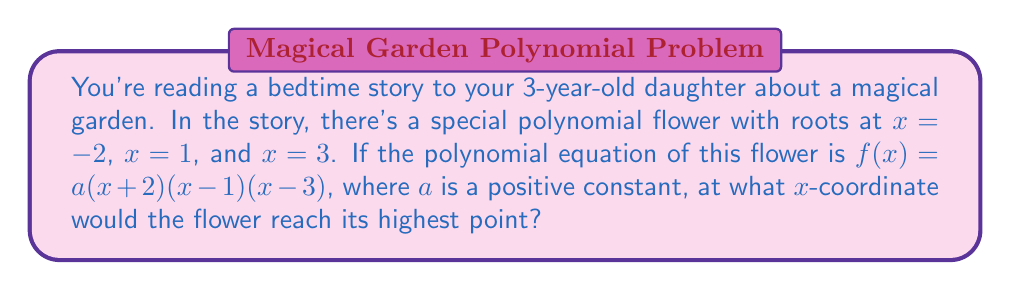What is the answer to this math problem? Let's approach this step-by-step:

1) The roots of the polynomial are at $x = -2$, $x = 1$, and $x = 3$. These are the x-intercepts of the graph.

2) Since $a$ is positive, the polynomial will open upward, meaning it will have a minimum point between its roots rather than a maximum.

3) To find the highest point (the maximum), we need to find the x-coordinate of the vertex of the parabola formed by the two outer roots.

4) The x-coordinate of the vertex of a parabola is always halfway between its roots.

5) The outer roots are at $x = -2$ and $x = 3$.

6) To find the midpoint between these roots, we use the formula:
   $$\frac{-2 + 3}{2} = \frac{1}{2} = 0.5$$

7) Therefore, the x-coordinate of the highest point of the flower would be at $x = 0.5$.

This point represents where the magical flower would reach its peak in the story's garden.
Answer: $x = 0.5$ 